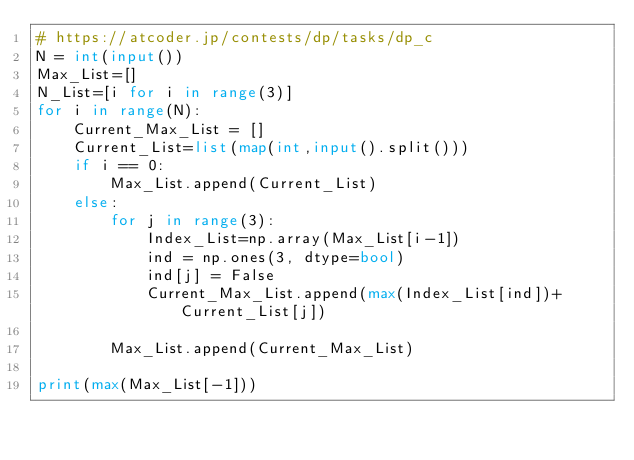Convert code to text. <code><loc_0><loc_0><loc_500><loc_500><_Python_># https://atcoder.jp/contests/dp/tasks/dp_c
N = int(input())
Max_List=[]
N_List=[i for i in range(3)]
for i in range(N):
    Current_Max_List = []
    Current_List=list(map(int,input().split())) 
    if i == 0:
        Max_List.append(Current_List)
    else:
        for j in range(3):
            Index_List=np.array(Max_List[i-1])
            ind = np.ones(3, dtype=bool)
            ind[j] = False
            Current_Max_List.append(max(Index_List[ind])+Current_List[j])
            
        Max_List.append(Current_Max_List)
 
print(max(Max_List[-1]))</code> 